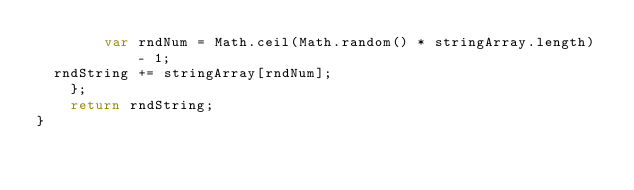Convert code to text. <code><loc_0><loc_0><loc_500><loc_500><_JavaScript_>        var rndNum = Math.ceil(Math.random() * stringArray.length) - 1;
	rndString += stringArray[rndNum];
    };
    return rndString;
}
</code> 